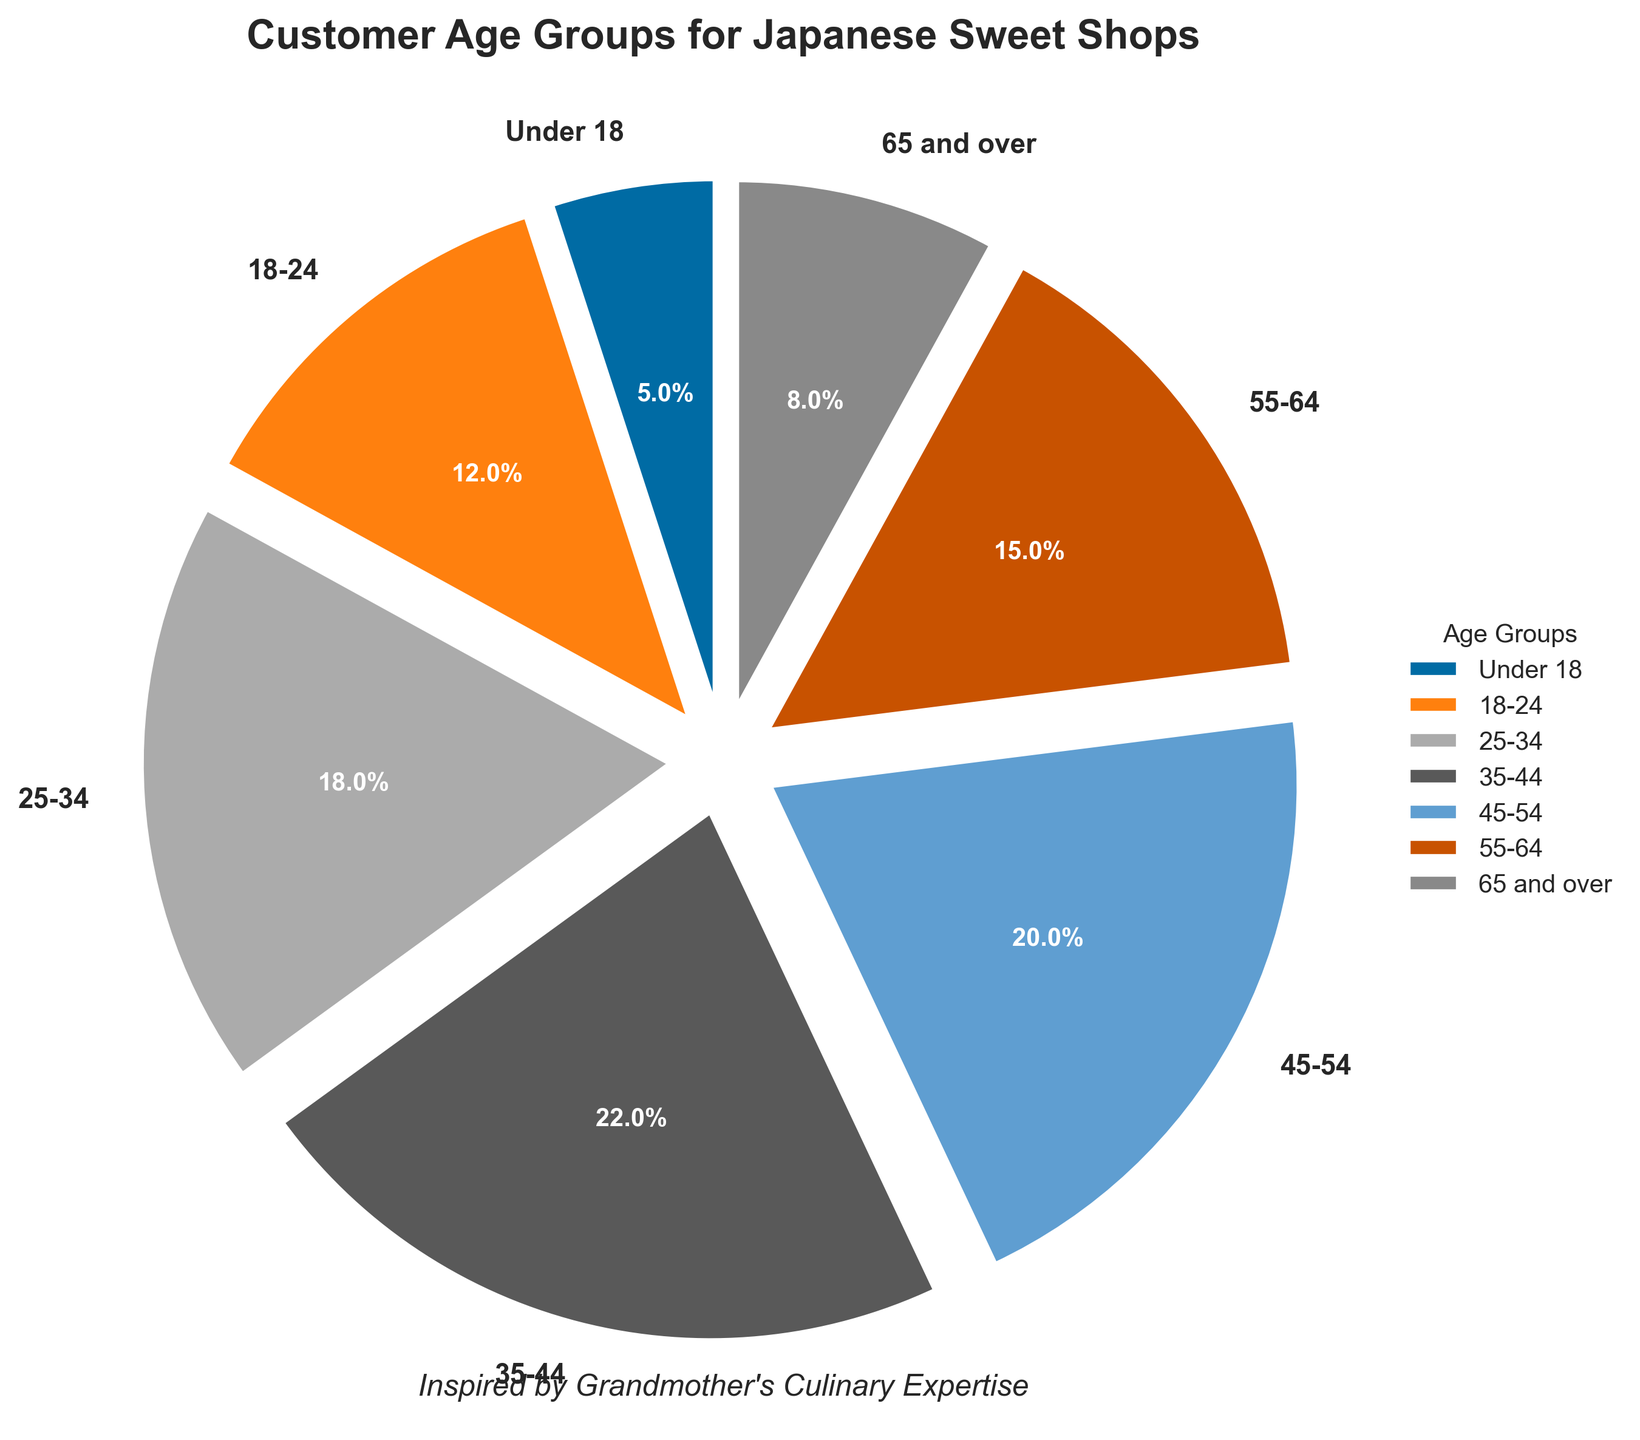What age group forms the largest customer base for Japanese sweet shops? By examining the pie chart, the section with the largest size is labeled "35-44." This indicates that the age group 35-44 has the highest percentage among the customer base.
Answer: 35-44 What is the total percentage of customers aged 18-34? To find this, sum the percentages of the age groups 18-24 and 25-34. From the pie chart: 12% (18-24) + 18% (25-34) = 30%.
Answer: 30% Which age group makes up a smaller proportion of the customer base, under 18 or 65 and over? By looking at the pie chart, you can compare the sizes of the sections for "Under 18" and "65 and over." The "Under 18" section is smaller.
Answer: Under 18 What is the combined percentage of customers aged 45 and over? Sum the percentages for the age groups 45-54, 55-64, and 65 and over. From the pie chart: 20% (45-54) + 15% (55-64) + 8% (65 and over) = 43%.
Answer: 43% How much larger is the percentage of customers aged 35-44 compared to those aged 18-24? Subtract the percentage of the 18-24 age group from the 35-44 age group. From the pie chart: 22% (35-44) - 12% (18-24) = 10%.
Answer: 10% Which two age groups have almost the same proportion of customers? By inspecting the chart, the sections for the age groups 25-34 (18%) and 55-64 (15%) appear to be the closest in size, with a small difference of 3%.
Answer: 25-34 and 55-64 What's the percentage difference between the largest and smallest age groups? The largest percentage is 35-44 at 22%, and the smallest is Under 18 at 5%. Subtracting these: 22% - 5% = 17%.
Answer: 17% Which age group comprises less than 10% of the customer base? The chart shows that the "Under 18" and "65 and over" age groups are both less than 10%.
Answer: Under 18 and 65 and over How does the percentage of customers aged 25-34 compare to those aged 55-64? The pie chart shows that 25-34 is 18% and 55-64 is 15%. Thus, the percentage of customers aged 25-34 is greater.
Answer: Greater 